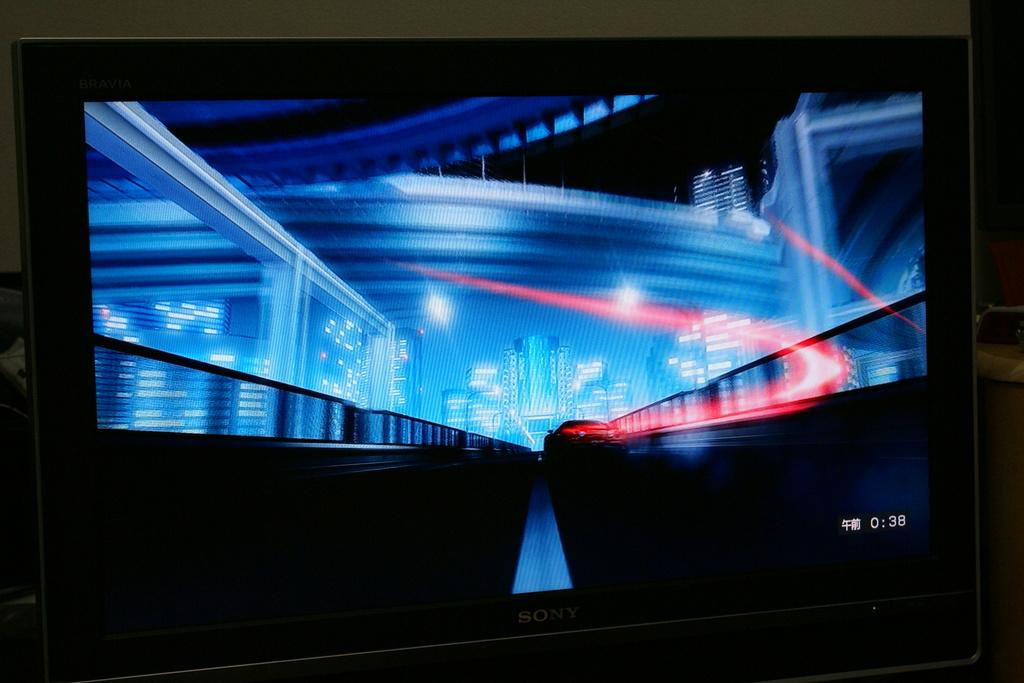<image>
Summarize the visual content of the image. The digital display of a cityscape in blue has a timer in the bottom corner that reads 0:38. 